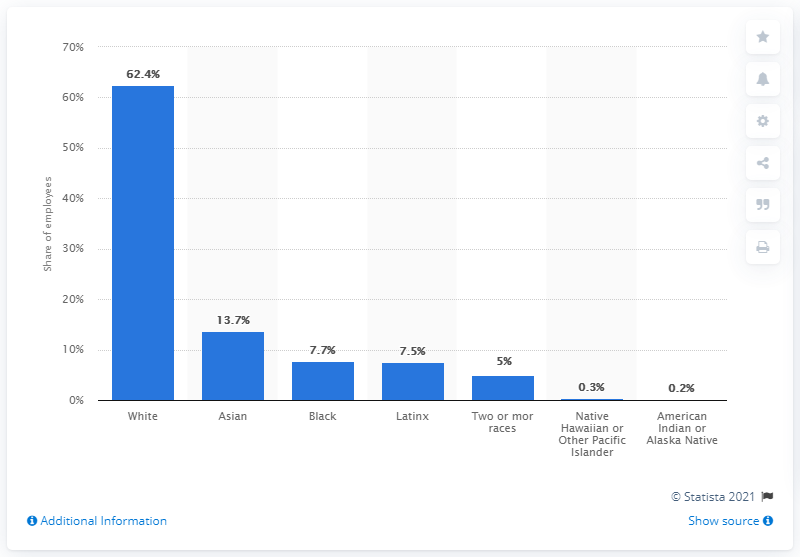Highlight a few significant elements in this photo. According to a report, 13.7 percent of BuzzFeed employees belong to the Asian ethnicity. 